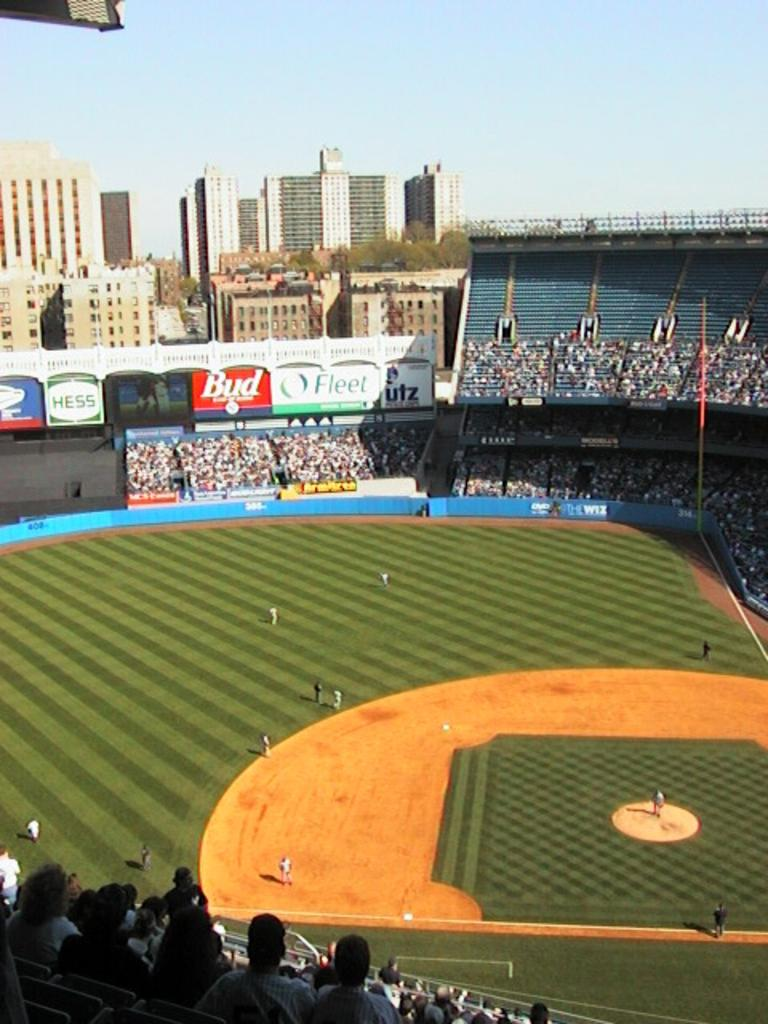<image>
Give a short and clear explanation of the subsequent image. a field with the word Bud in the outfield 